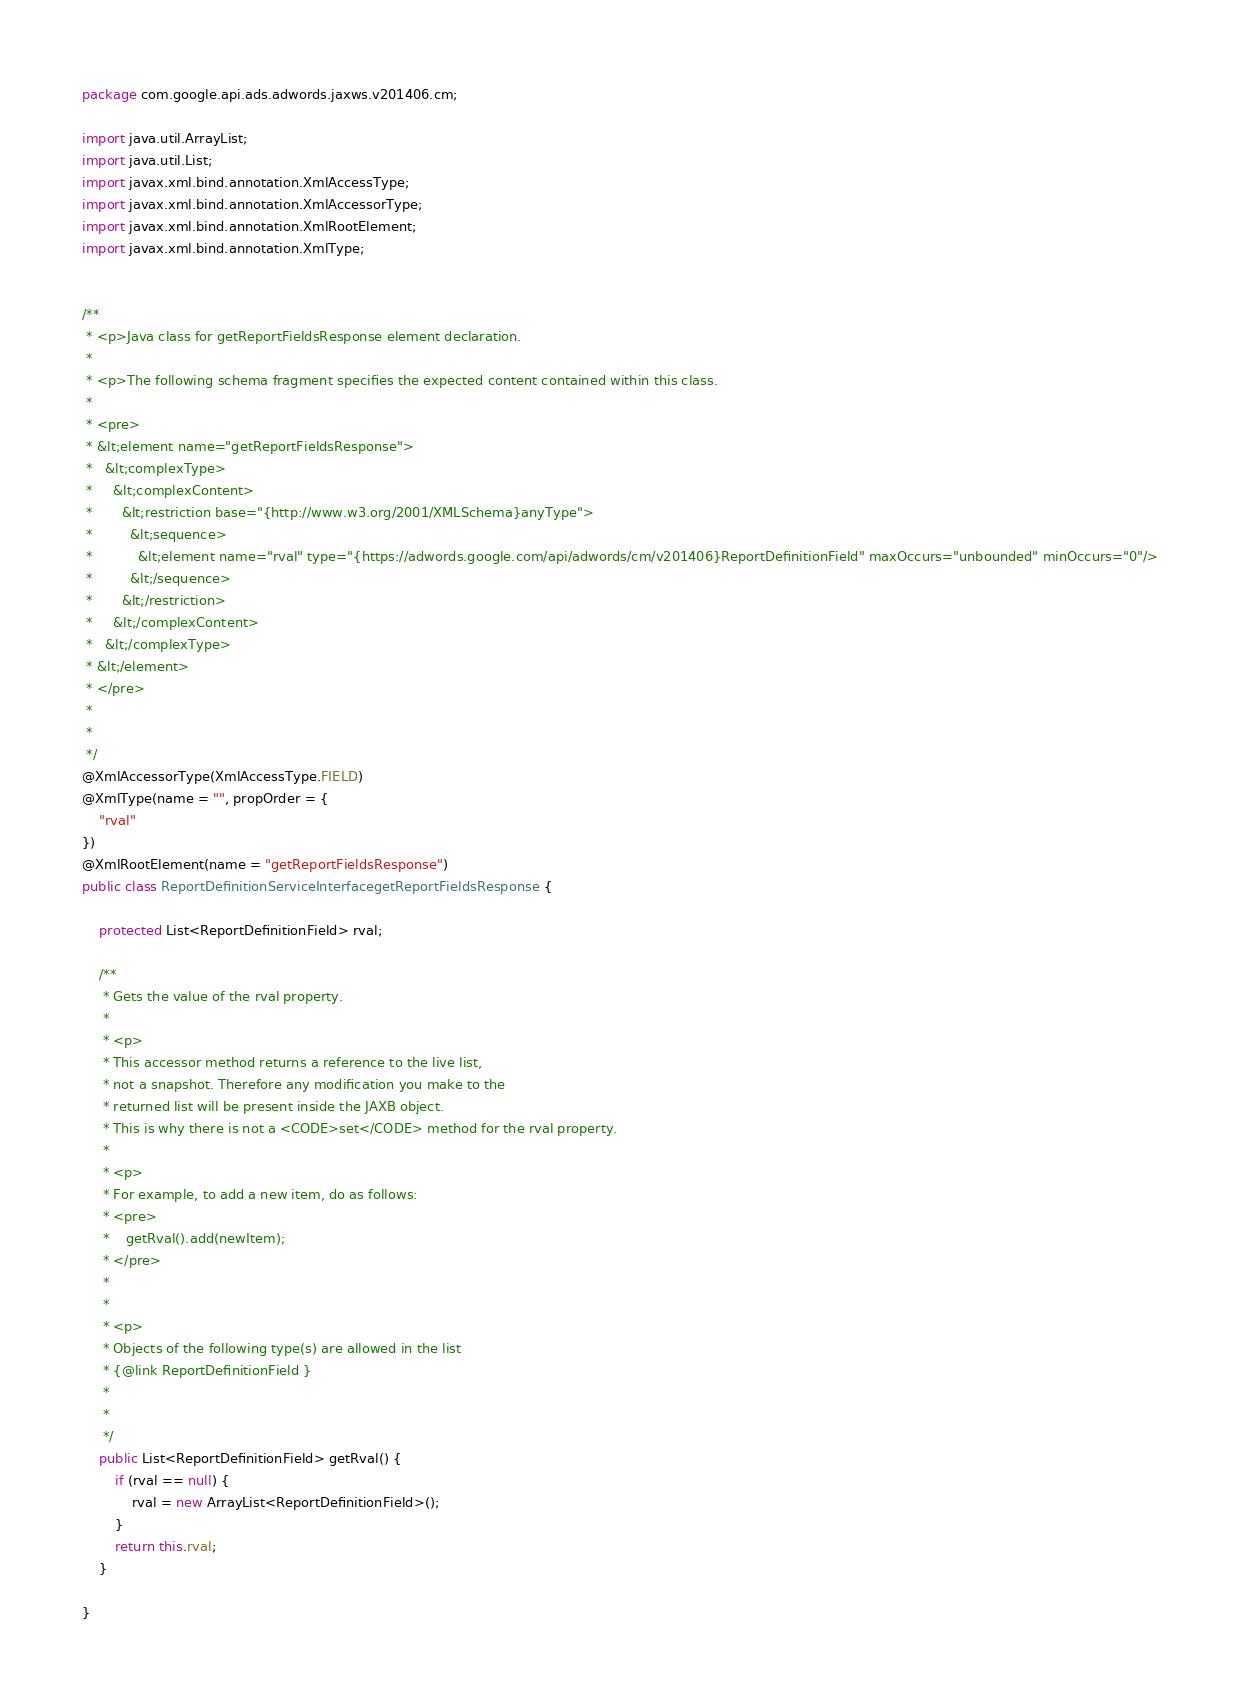Convert code to text. <code><loc_0><loc_0><loc_500><loc_500><_Java_>
package com.google.api.ads.adwords.jaxws.v201406.cm;

import java.util.ArrayList;
import java.util.List;
import javax.xml.bind.annotation.XmlAccessType;
import javax.xml.bind.annotation.XmlAccessorType;
import javax.xml.bind.annotation.XmlRootElement;
import javax.xml.bind.annotation.XmlType;


/**
 * <p>Java class for getReportFieldsResponse element declaration.
 * 
 * <p>The following schema fragment specifies the expected content contained within this class.
 * 
 * <pre>
 * &lt;element name="getReportFieldsResponse">
 *   &lt;complexType>
 *     &lt;complexContent>
 *       &lt;restriction base="{http://www.w3.org/2001/XMLSchema}anyType">
 *         &lt;sequence>
 *           &lt;element name="rval" type="{https://adwords.google.com/api/adwords/cm/v201406}ReportDefinitionField" maxOccurs="unbounded" minOccurs="0"/>
 *         &lt;/sequence>
 *       &lt;/restriction>
 *     &lt;/complexContent>
 *   &lt;/complexType>
 * &lt;/element>
 * </pre>
 * 
 * 
 */
@XmlAccessorType(XmlAccessType.FIELD)
@XmlType(name = "", propOrder = {
    "rval"
})
@XmlRootElement(name = "getReportFieldsResponse")
public class ReportDefinitionServiceInterfacegetReportFieldsResponse {

    protected List<ReportDefinitionField> rval;

    /**
     * Gets the value of the rval property.
     * 
     * <p>
     * This accessor method returns a reference to the live list,
     * not a snapshot. Therefore any modification you make to the
     * returned list will be present inside the JAXB object.
     * This is why there is not a <CODE>set</CODE> method for the rval property.
     * 
     * <p>
     * For example, to add a new item, do as follows:
     * <pre>
     *    getRval().add(newItem);
     * </pre>
     * 
     * 
     * <p>
     * Objects of the following type(s) are allowed in the list
     * {@link ReportDefinitionField }
     * 
     * 
     */
    public List<ReportDefinitionField> getRval() {
        if (rval == null) {
            rval = new ArrayList<ReportDefinitionField>();
        }
        return this.rval;
    }

}
</code> 